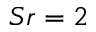Convert formula to latex. <formula><loc_0><loc_0><loc_500><loc_500>S r = 2</formula> 